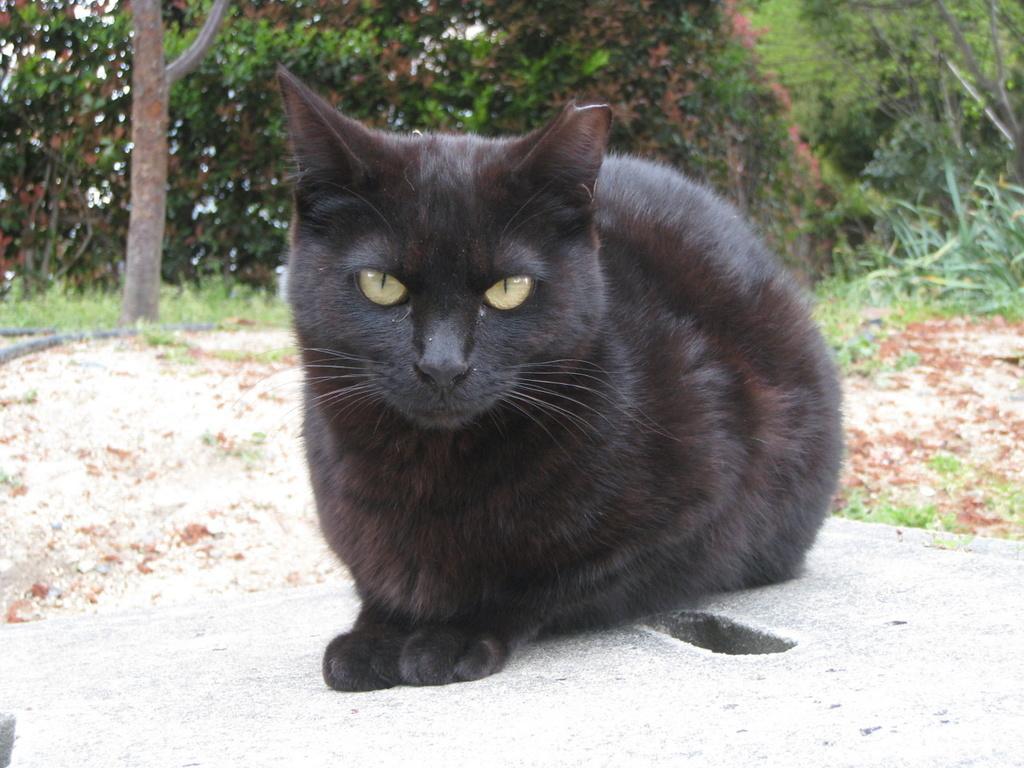How would you summarize this image in a sentence or two? In the picture I can see black cat sitting on the floor, behind we can see so many trees. 